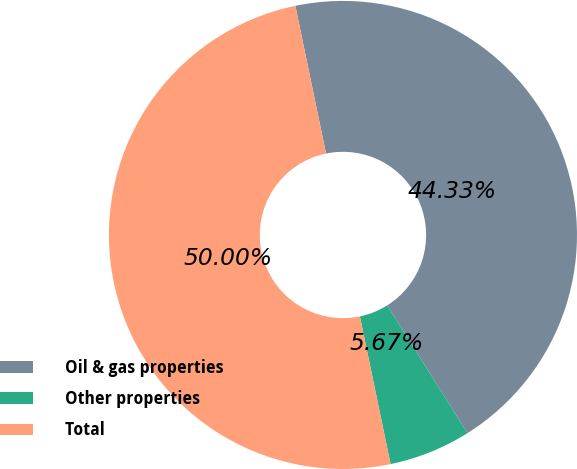<chart> <loc_0><loc_0><loc_500><loc_500><pie_chart><fcel>Oil & gas properties<fcel>Other properties<fcel>Total<nl><fcel>44.33%<fcel>5.67%<fcel>50.0%<nl></chart> 